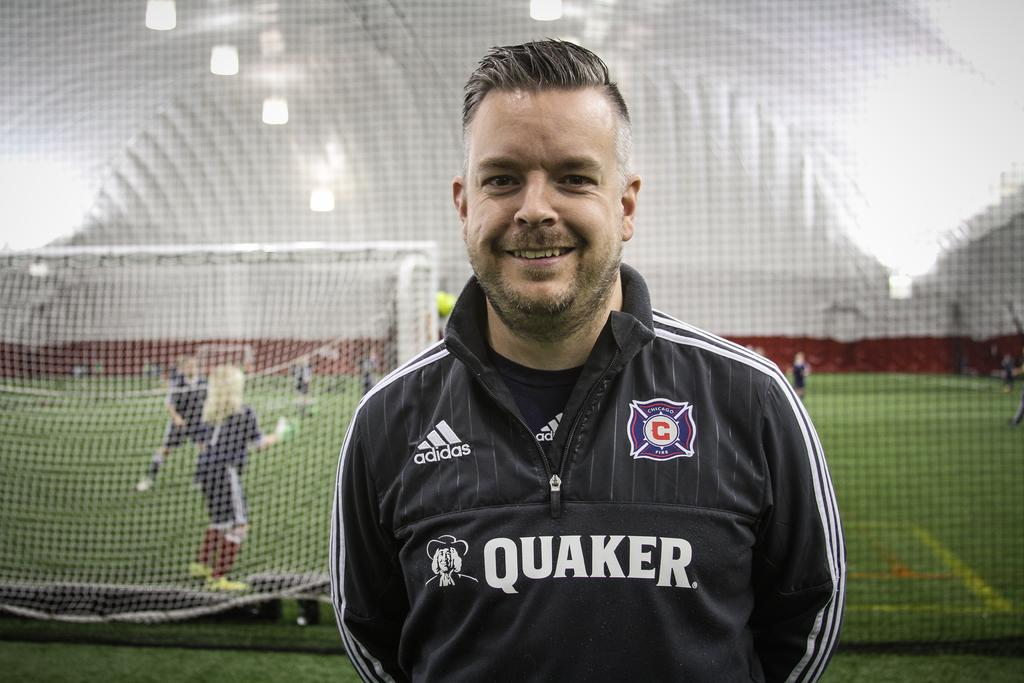What is the person in the image doing? The person in the image is watching and smiling. What can be seen in the background of the image? There is a net, rods, people, and the ground visible in the background of the image. Can you describe the activity taking place in the background? The presence of a net and rods suggests that there might be a sport or game being played in the background. What type of nut is being used to paint on the canvas in the image? There is no nut or canvas present in the image; it features a person watching and smiling with a background that includes a net, rods, people, and the ground. 